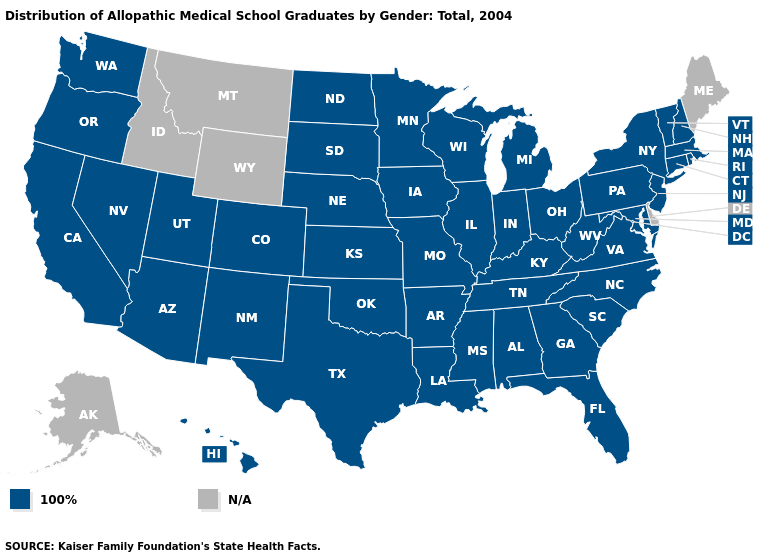Does the map have missing data?
Be succinct. Yes. Name the states that have a value in the range N/A?
Keep it brief. Alaska, Delaware, Idaho, Maine, Montana, Wyoming. Is the legend a continuous bar?
Quick response, please. No. Name the states that have a value in the range N/A?
Concise answer only. Alaska, Delaware, Idaho, Maine, Montana, Wyoming. Among the states that border Pennsylvania , which have the lowest value?
Keep it brief. Maryland, New Jersey, New York, Ohio, West Virginia. Among the states that border Wisconsin , which have the lowest value?
Quick response, please. Illinois, Iowa, Michigan, Minnesota. How many symbols are there in the legend?
Quick response, please. 2. Is the legend a continuous bar?
Be succinct. No. Which states hav the highest value in the South?
Answer briefly. Alabama, Arkansas, Florida, Georgia, Kentucky, Louisiana, Maryland, Mississippi, North Carolina, Oklahoma, South Carolina, Tennessee, Texas, Virginia, West Virginia. Name the states that have a value in the range 100%?
Be succinct. Alabama, Arizona, Arkansas, California, Colorado, Connecticut, Florida, Georgia, Hawaii, Illinois, Indiana, Iowa, Kansas, Kentucky, Louisiana, Maryland, Massachusetts, Michigan, Minnesota, Mississippi, Missouri, Nebraska, Nevada, New Hampshire, New Jersey, New Mexico, New York, North Carolina, North Dakota, Ohio, Oklahoma, Oregon, Pennsylvania, Rhode Island, South Carolina, South Dakota, Tennessee, Texas, Utah, Vermont, Virginia, Washington, West Virginia, Wisconsin. What is the value of North Carolina?
Write a very short answer. 100%. Name the states that have a value in the range N/A?
Keep it brief. Alaska, Delaware, Idaho, Maine, Montana, Wyoming. Name the states that have a value in the range N/A?
Short answer required. Alaska, Delaware, Idaho, Maine, Montana, Wyoming. Is the legend a continuous bar?
Concise answer only. No. What is the value of North Dakota?
Answer briefly. 100%. 